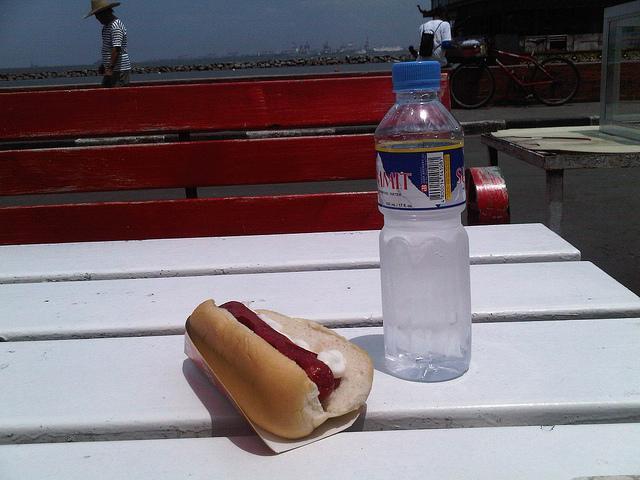How many dining tables can you see?
Give a very brief answer. 2. How many bears are in this picture?
Give a very brief answer. 0. 